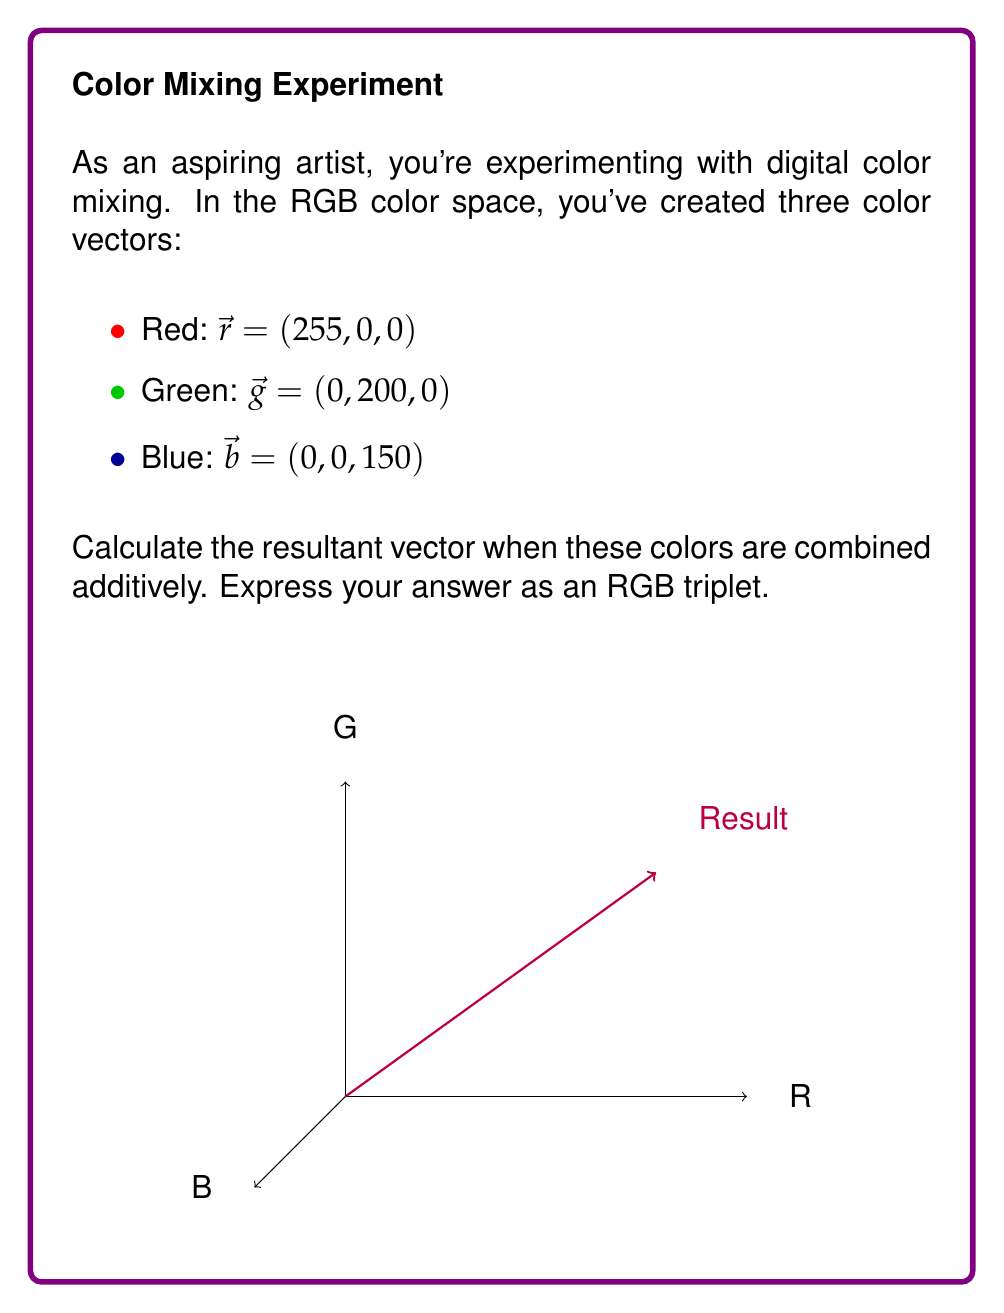Teach me how to tackle this problem. To calculate the resultant vector when combining color vectors in RGB space, we need to add the corresponding components of each vector:

1) First, let's identify the components of each vector:
   $\vec{r} = (255, 0, 0)$
   $\vec{g} = (0, 200, 0)$
   $\vec{b} = (0, 0, 150)$

2) Now, we add the corresponding components:
   Red component: $255 + 0 + 0 = 255$
   Green component: $0 + 200 + 0 = 200$
   Blue component: $0 + 0 + 150 = 150$

3) The resultant vector is the sum of these components:
   $$\vec{result} = \vec{r} + \vec{g} + \vec{b} = (255, 200, 150)$$

4) In RGB color space, color values are typically capped at 255. Since none of our components exceed 255, no adjustment is needed.

Therefore, the final resultant color vector in RGB space is (255, 200, 150).
Answer: (255, 200, 150) 